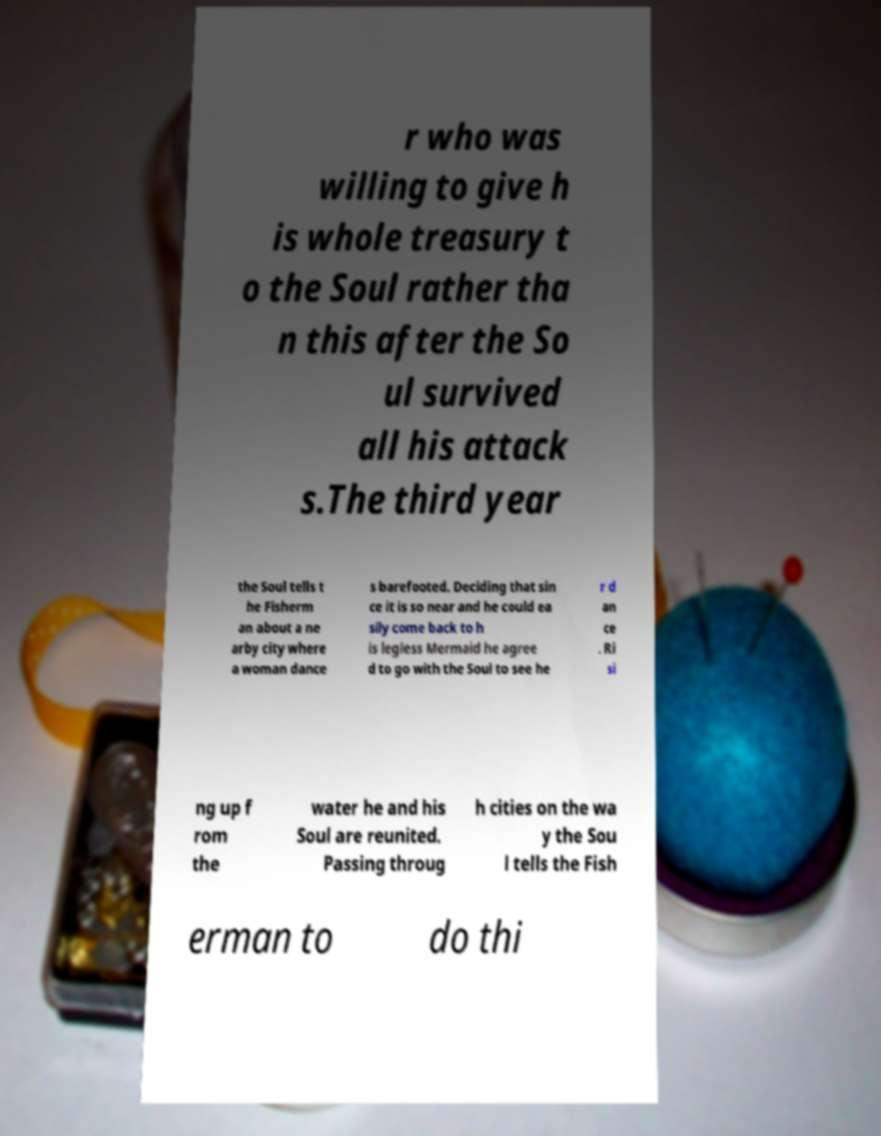I need the written content from this picture converted into text. Can you do that? r who was willing to give h is whole treasury t o the Soul rather tha n this after the So ul survived all his attack s.The third year the Soul tells t he Fisherm an about a ne arby city where a woman dance s barefooted. Deciding that sin ce it is so near and he could ea sily come back to h is legless Mermaid he agree d to go with the Soul to see he r d an ce . Ri si ng up f rom the water he and his Soul are reunited. Passing throug h cities on the wa y the Sou l tells the Fish erman to do thi 